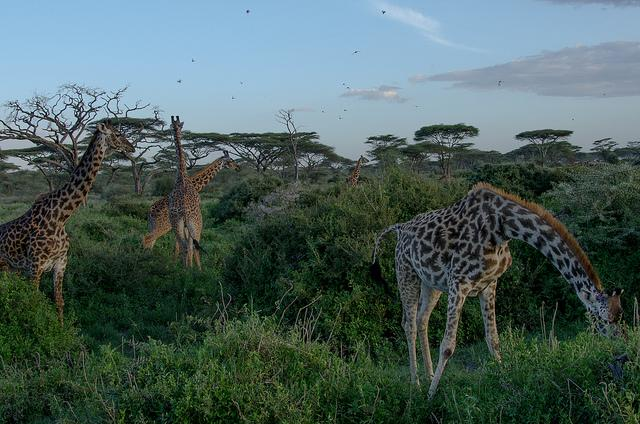How many giraffes can clearly be seen grazing in the area? Please explain your reasoning. five. Two giraffes are immediately apparent in this image in the foreground and to the left. two more overlap each other in the middle left, and one more is in the center background. 